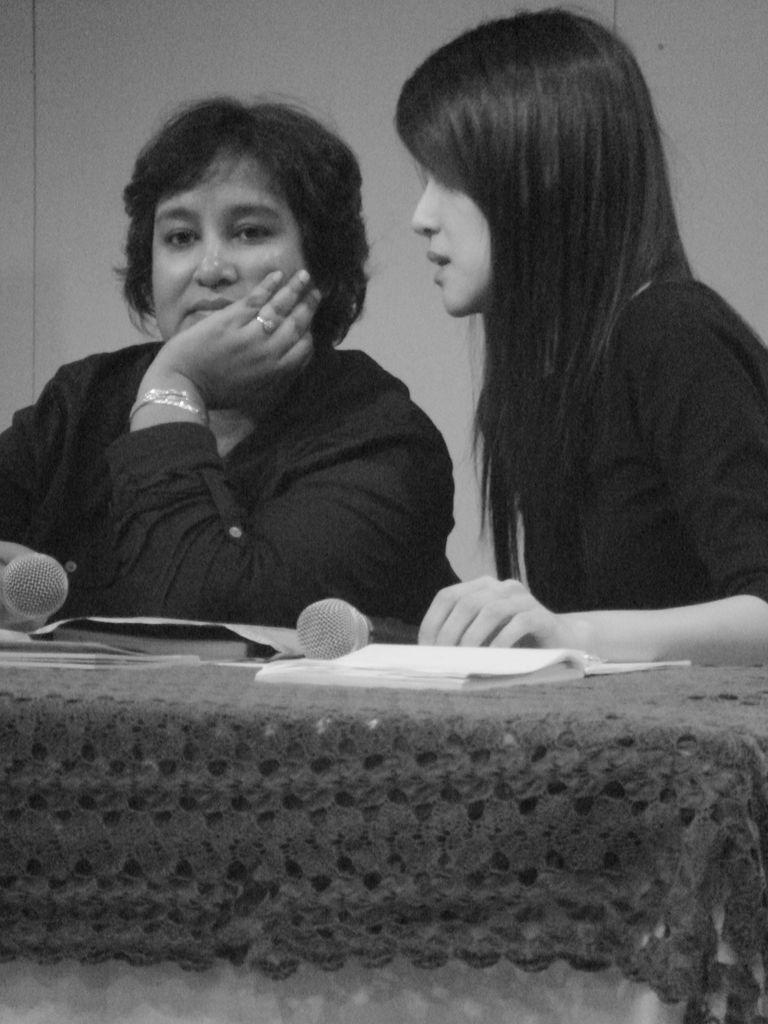How many women are in the image? There are two women in the image. What objects are in front of the women? There are microphones, books, and other objects in front of the women. What can be seen in the background of the image? There is a wall in the background of the image. Where is the shelf located in the image? There is no shelf present in the image. Can you tell me the name of the uncle in the image? There is no uncle present in the image. 